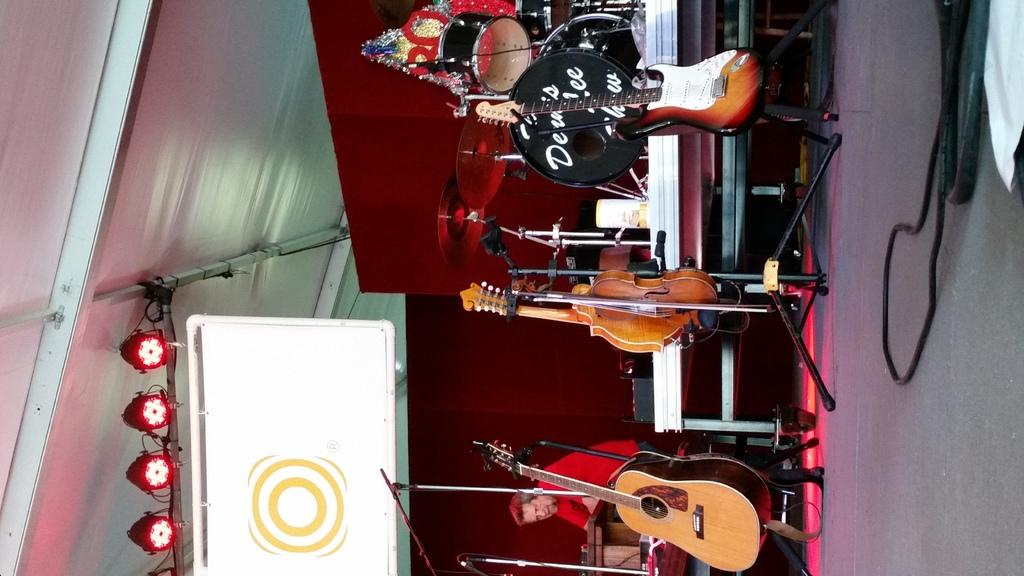What is the man in the image doing? The man is standing on a stage in the image. What can be seen on the floor near the stage? There is a group of musical instruments on the floor in the image. What type of lighting is present in the image? There is a stage light in the image. What is the white object in the image? There is a white board in the image. What color are the man's eyes in the image? The image does not show the man's eyes, so we cannot determine their color. 